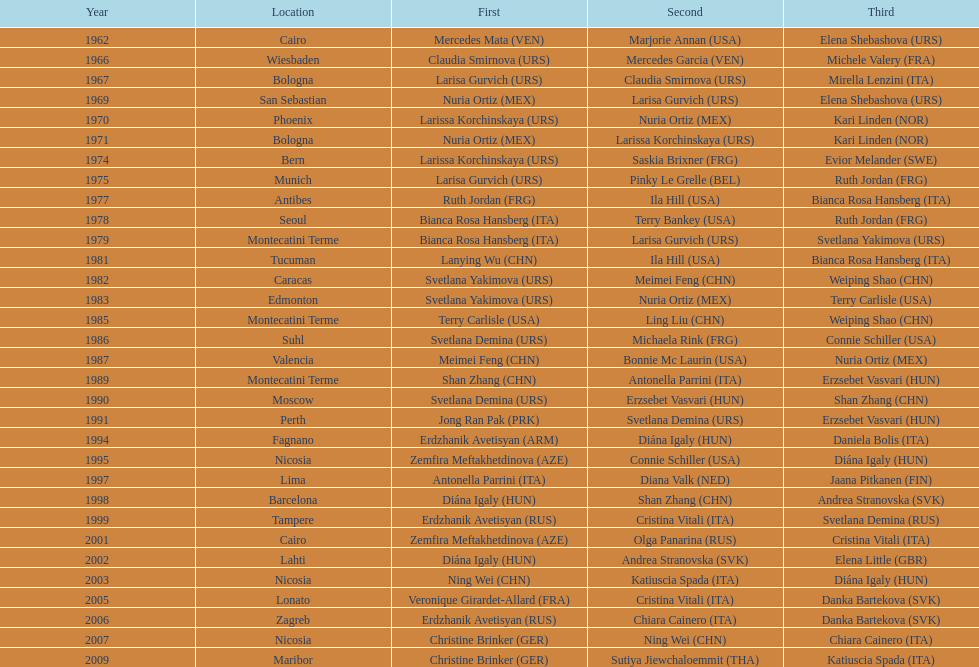Which country has won more gold medals: china or mexico? China. 